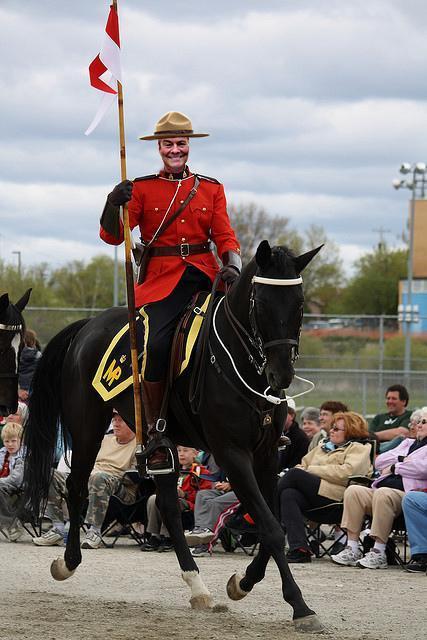How many people are in the picture?
Give a very brief answer. 5. 